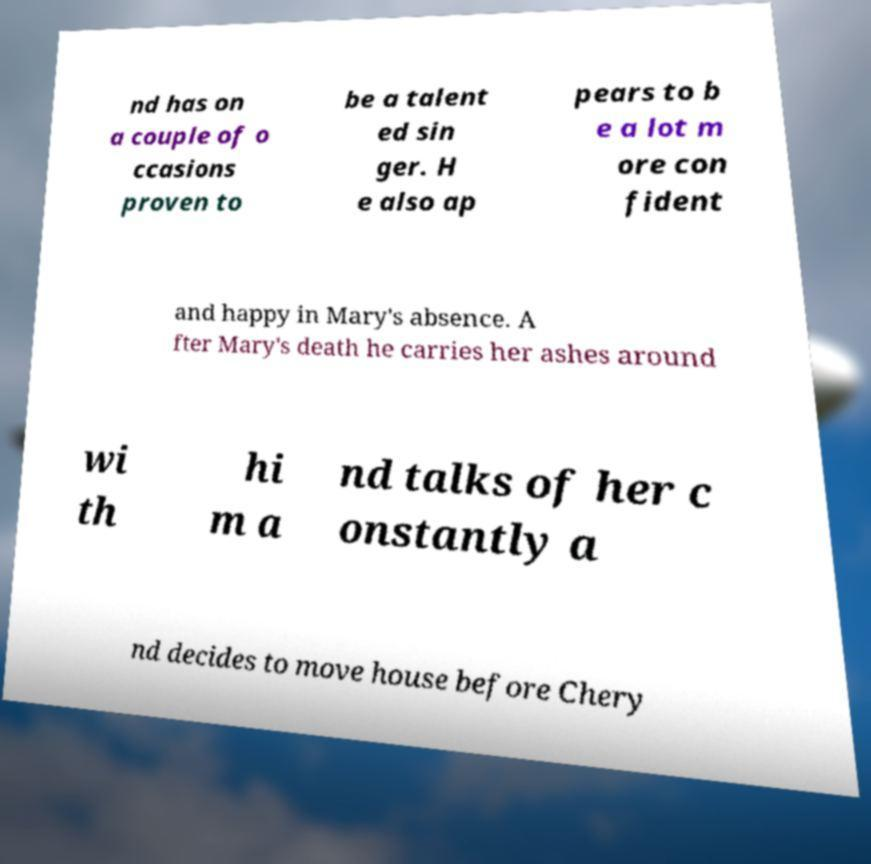What messages or text are displayed in this image? I need them in a readable, typed format. nd has on a couple of o ccasions proven to be a talent ed sin ger. H e also ap pears to b e a lot m ore con fident and happy in Mary's absence. A fter Mary's death he carries her ashes around wi th hi m a nd talks of her c onstantly a nd decides to move house before Chery 